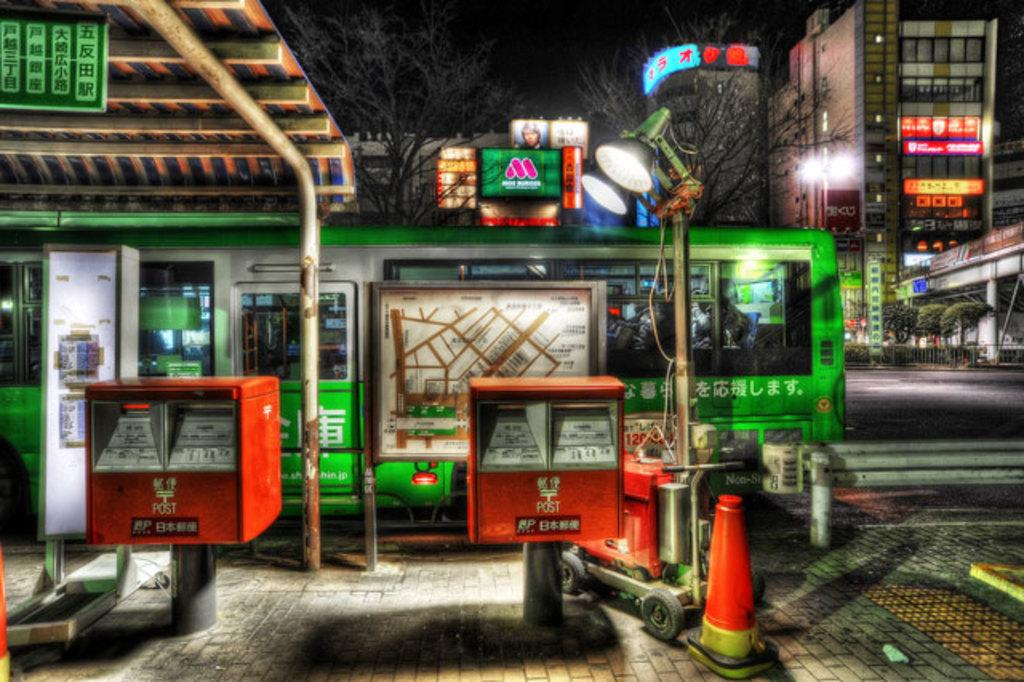<image>
Share a concise interpretation of the image provided. the word post is on the orange item outside 